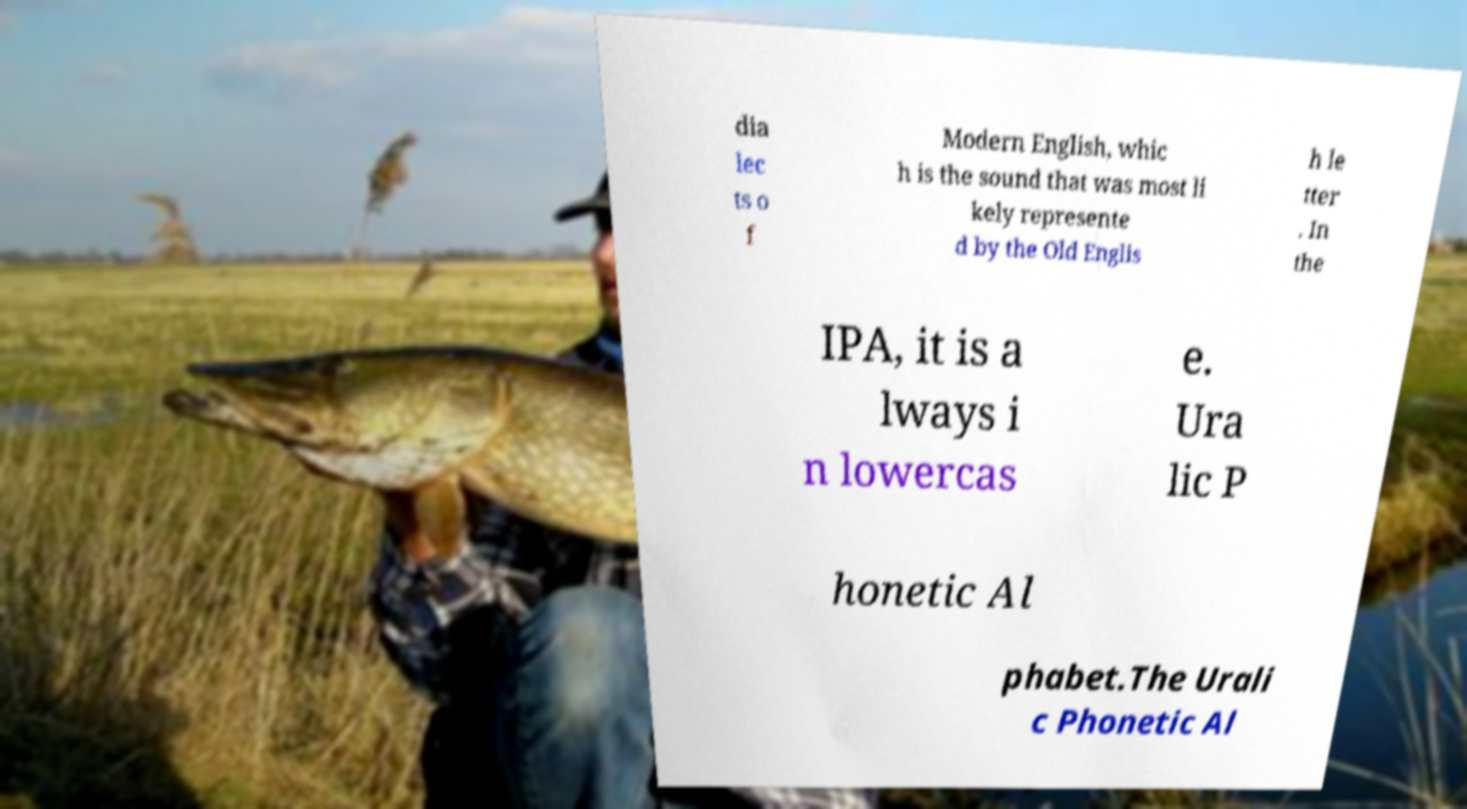What messages or text are displayed in this image? I need them in a readable, typed format. dia lec ts o f Modern English, whic h is the sound that was most li kely represente d by the Old Englis h le tter . In the IPA, it is a lways i n lowercas e. Ura lic P honetic Al phabet.The Urali c Phonetic Al 